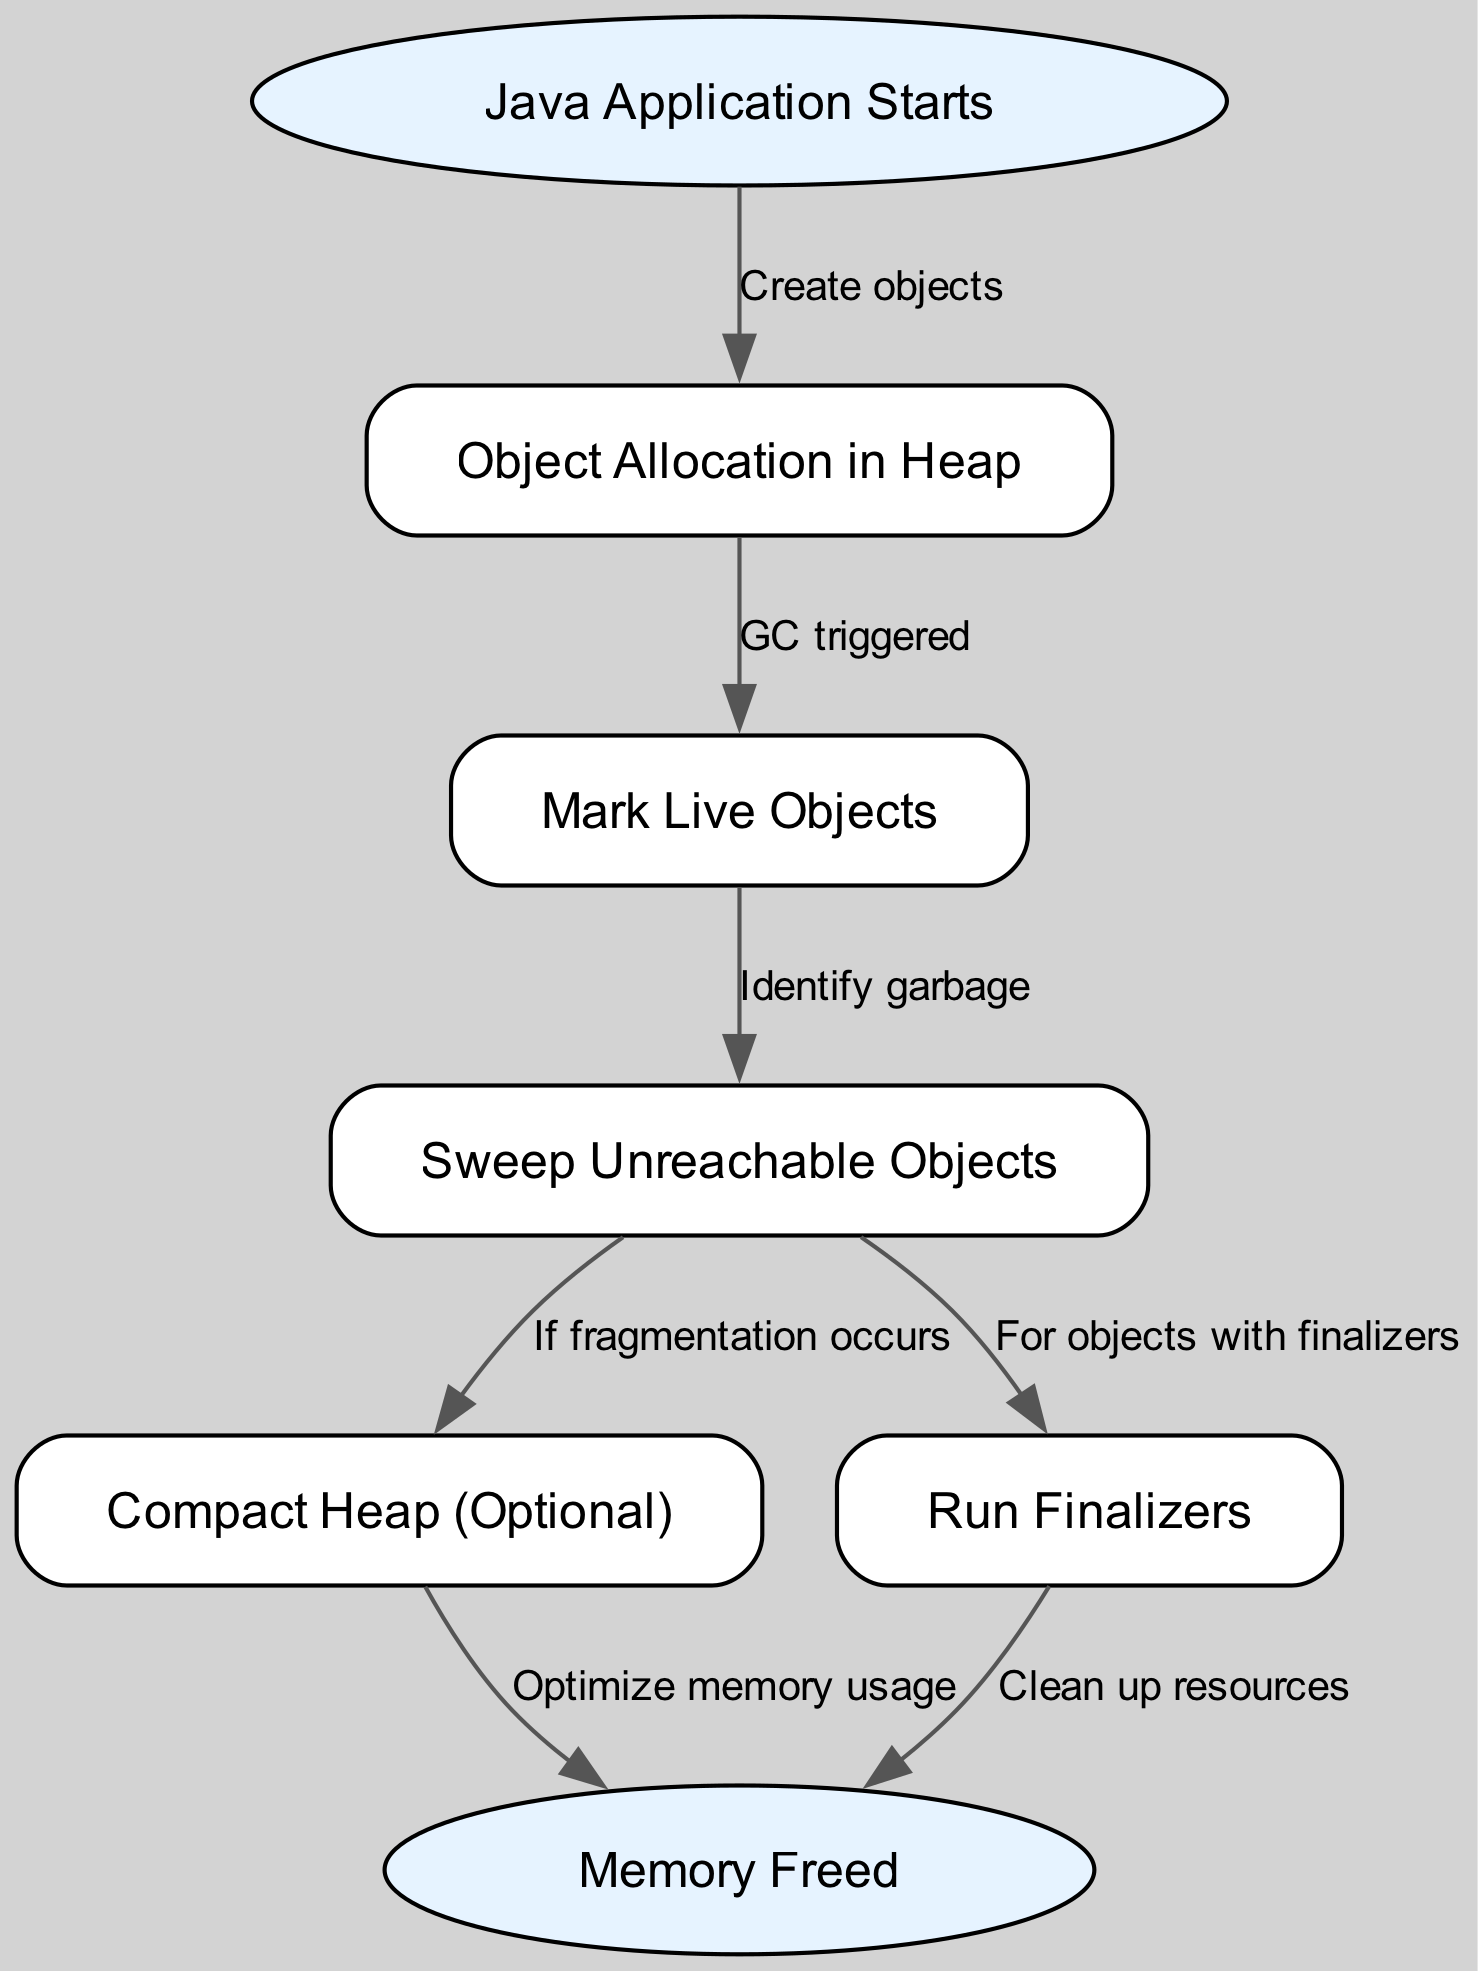What is the first step in the Java garbage collection lifecycle? The first step is represented by the node "Java Application Starts," which indicates the beginning of the process.
Answer: Java Application Starts How many nodes are present in the diagram? By counting the nodes listed in the data, there are a total of seven nodes: start, allocation, mark, sweep, compact, finalize, and end.
Answer: 7 What is the relationship between "allocation" and "mark"? The edge from allocation to mark indicates that the transition occurs when "GC triggered," which means that garbage collection initiates after object allocation.
Answer: GC triggered What happens after "sweep" if fragmentation occurs? If fragmentation occurs after the sweep, the next step in the flow is "Compact Heap (Optional)," indicating that compaction is done to optimize memory.
Answer: Compact Heap (Optional) Which node is reached after running finalizers? After the finalizers have been run, the next node in the flow is "Memory Freed," indicating that resource cleanup has been completed.
Answer: Memory Freed What step occurs when garbage collection is triggered? When garbage collection is triggered, it triggers the "Mark Live Objects" step, where live objects are marked to identify which memory can be freed.
Answer: Mark Live Objects What is the last operation in the garbage collection process? The last operation in the garbage collection process is indicated by the node "Memory Freed," which denotes the completion of memory management as resources are released.
Answer: Memory Freed What is the purpose of the "Compact" step in the diagram? The "Compact" step serves to optimize memory usage by rearranging live objects in the heap to reduce fragmentation after the sweep process.
Answer: Optimize memory usage What is the function of the "Finalize" step? The "Finalize" step is conducted to clean up resources for objects that have finalizers, ensuring that any necessary cleanup is executed.
Answer: Clean up resources 